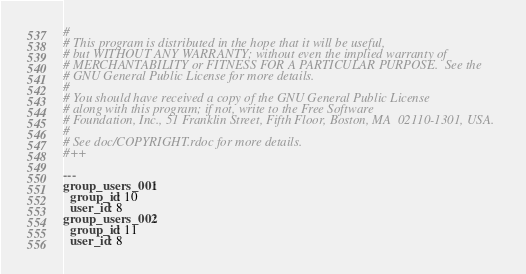Convert code to text. <code><loc_0><loc_0><loc_500><loc_500><_YAML_>#
# This program is distributed in the hope that it will be useful,
# but WITHOUT ANY WARRANTY; without even the implied warranty of
# MERCHANTABILITY or FITNESS FOR A PARTICULAR PURPOSE.  See the
# GNU General Public License for more details.
#
# You should have received a copy of the GNU General Public License
# along with this program; if not, write to the Free Software
# Foundation, Inc., 51 Franklin Street, Fifth Floor, Boston, MA  02110-1301, USA.
#
# See doc/COPYRIGHT.rdoc for more details.
#++

---
group_users_001:
  group_id: 10
  user_id: 8
group_users_002:
  group_id: 11
  user_id: 8

</code> 